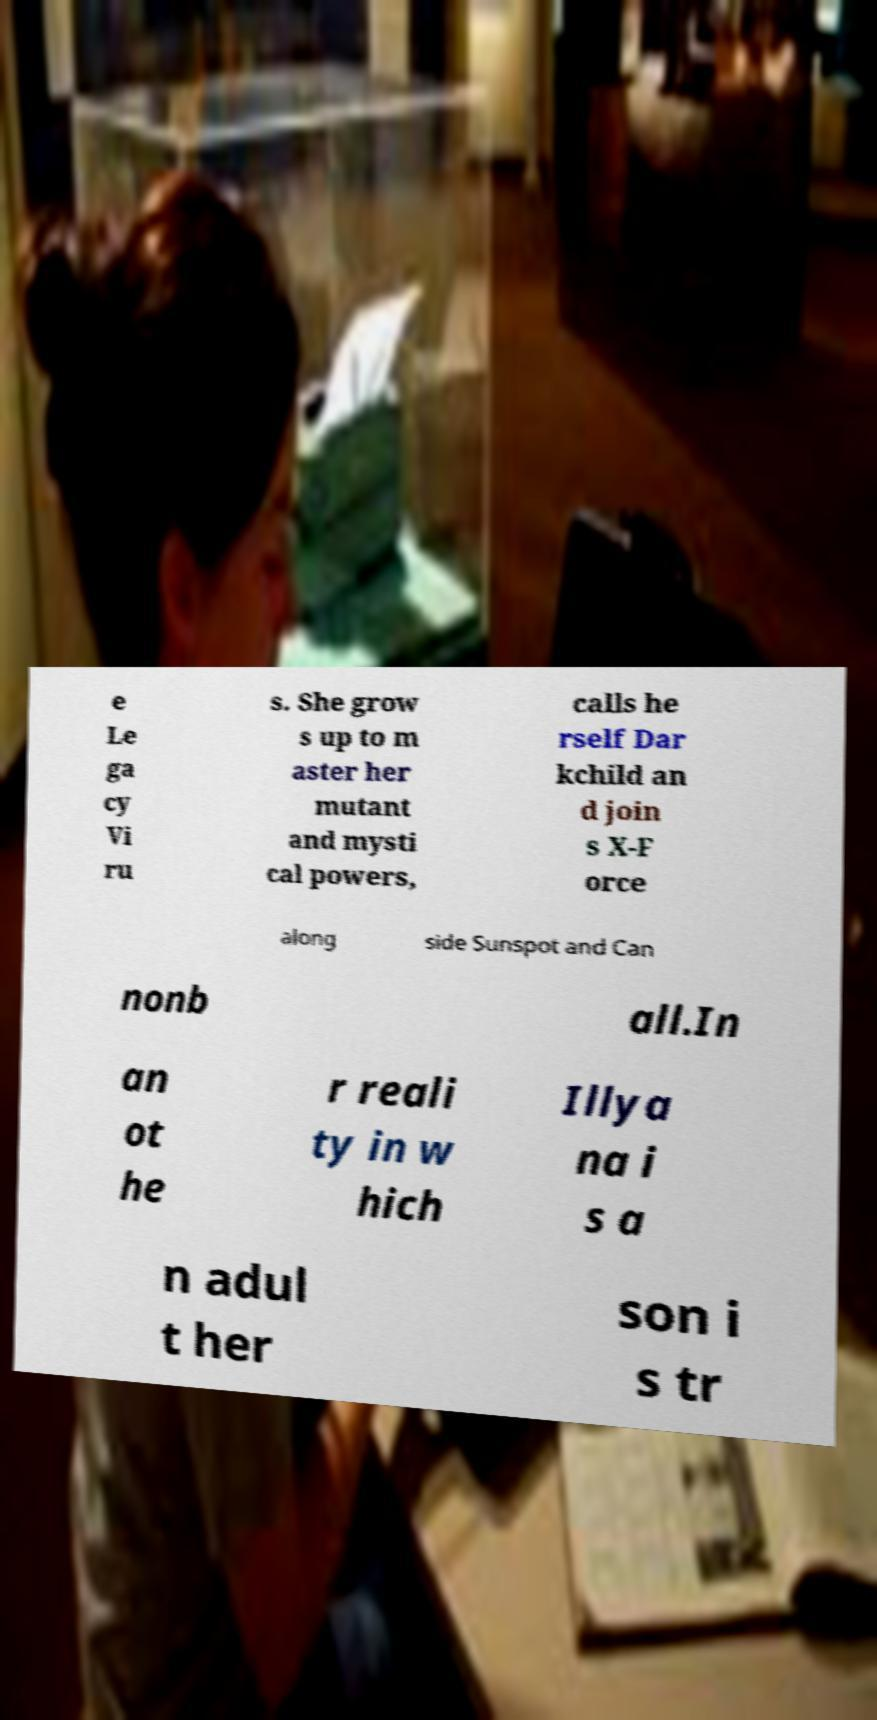Could you assist in decoding the text presented in this image and type it out clearly? e Le ga cy Vi ru s. She grow s up to m aster her mutant and mysti cal powers, calls he rself Dar kchild an d join s X-F orce along side Sunspot and Can nonb all.In an ot he r reali ty in w hich Illya na i s a n adul t her son i s tr 